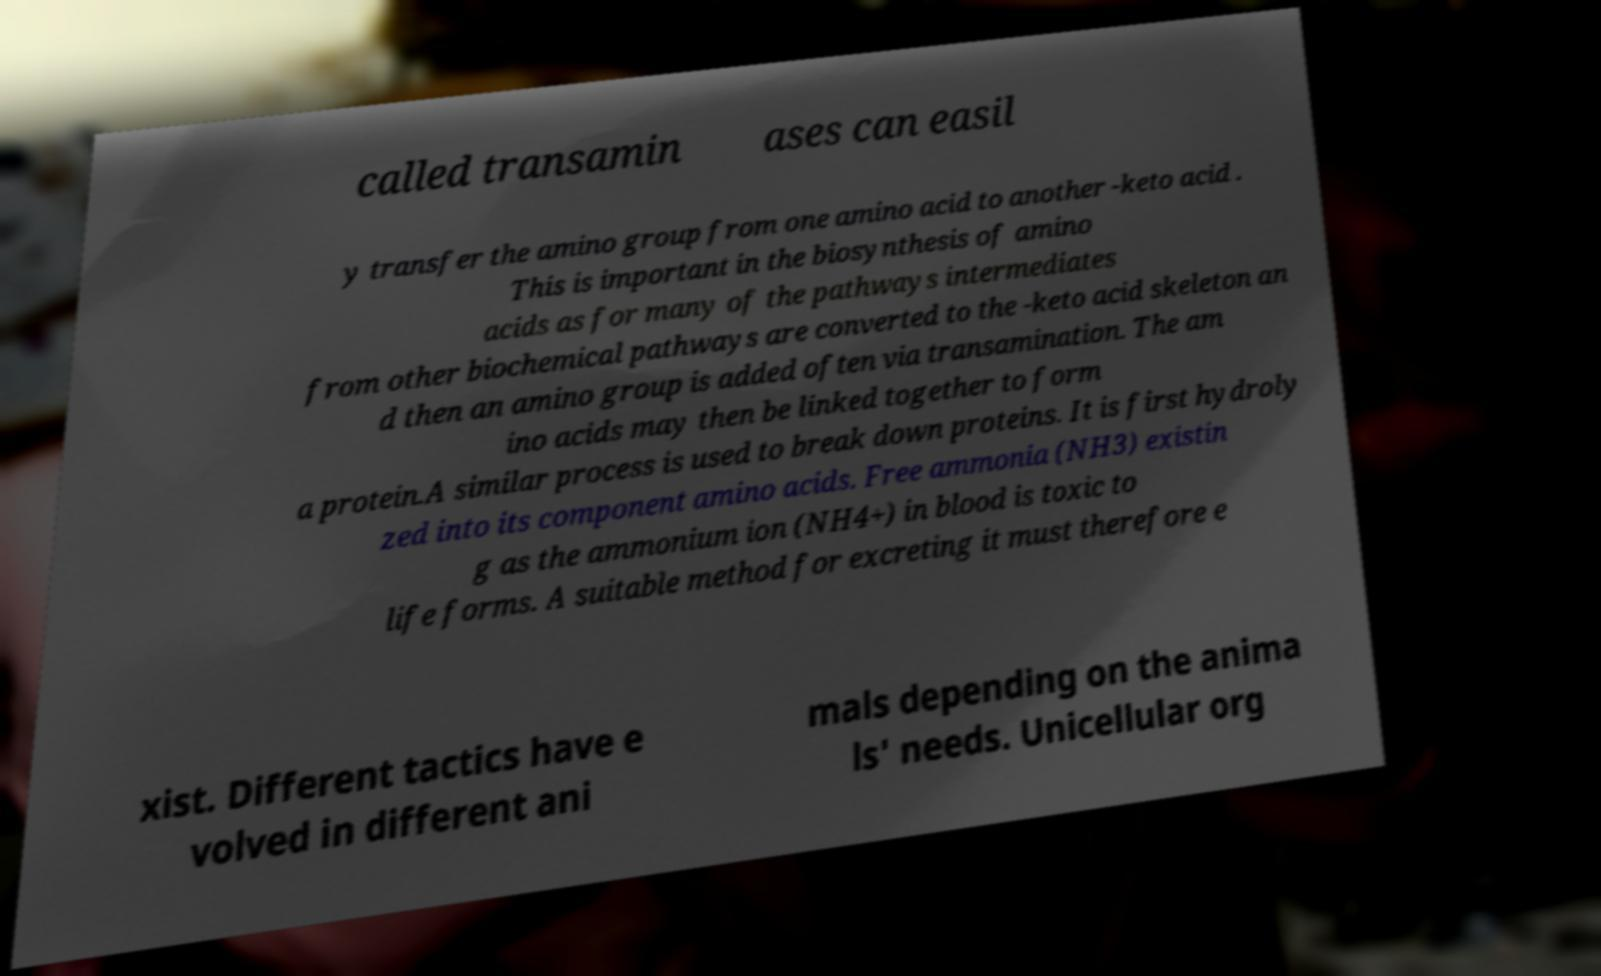What messages or text are displayed in this image? I need them in a readable, typed format. called transamin ases can easil y transfer the amino group from one amino acid to another -keto acid . This is important in the biosynthesis of amino acids as for many of the pathways intermediates from other biochemical pathways are converted to the -keto acid skeleton an d then an amino group is added often via transamination. The am ino acids may then be linked together to form a protein.A similar process is used to break down proteins. It is first hydroly zed into its component amino acids. Free ammonia (NH3) existin g as the ammonium ion (NH4+) in blood is toxic to life forms. A suitable method for excreting it must therefore e xist. Different tactics have e volved in different ani mals depending on the anima ls' needs. Unicellular org 